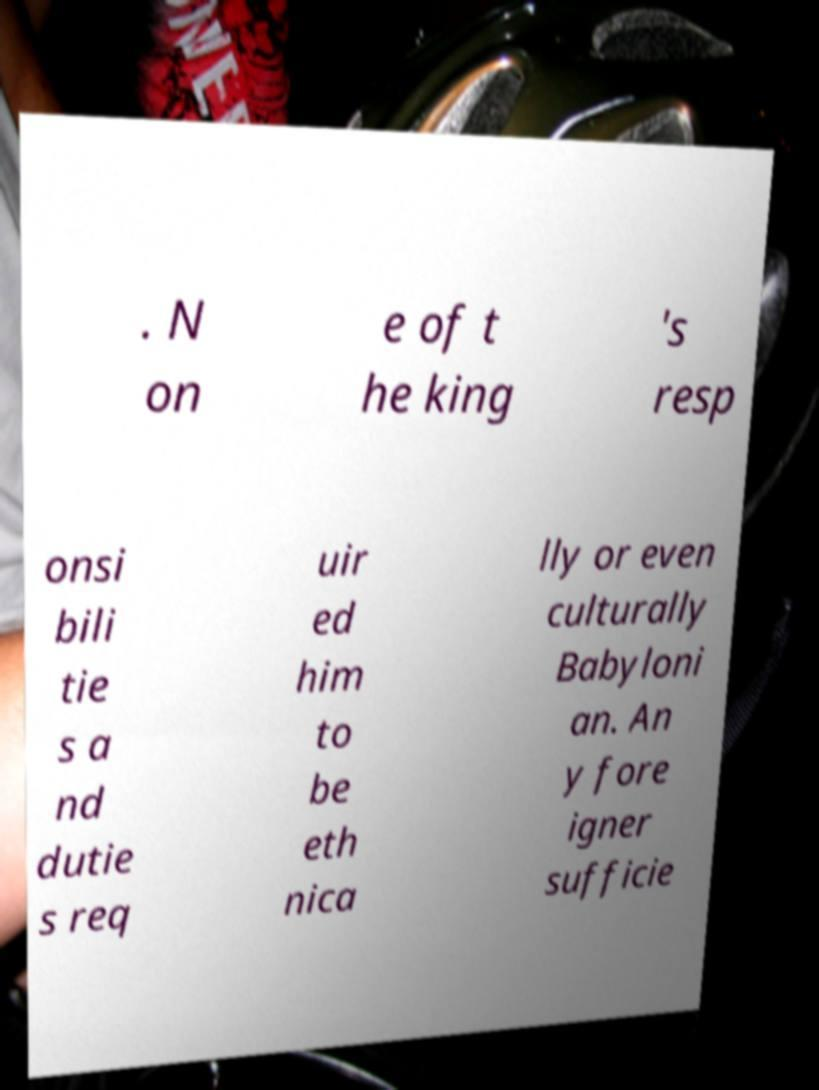I need the written content from this picture converted into text. Can you do that? . N on e of t he king 's resp onsi bili tie s a nd dutie s req uir ed him to be eth nica lly or even culturally Babyloni an. An y fore igner sufficie 